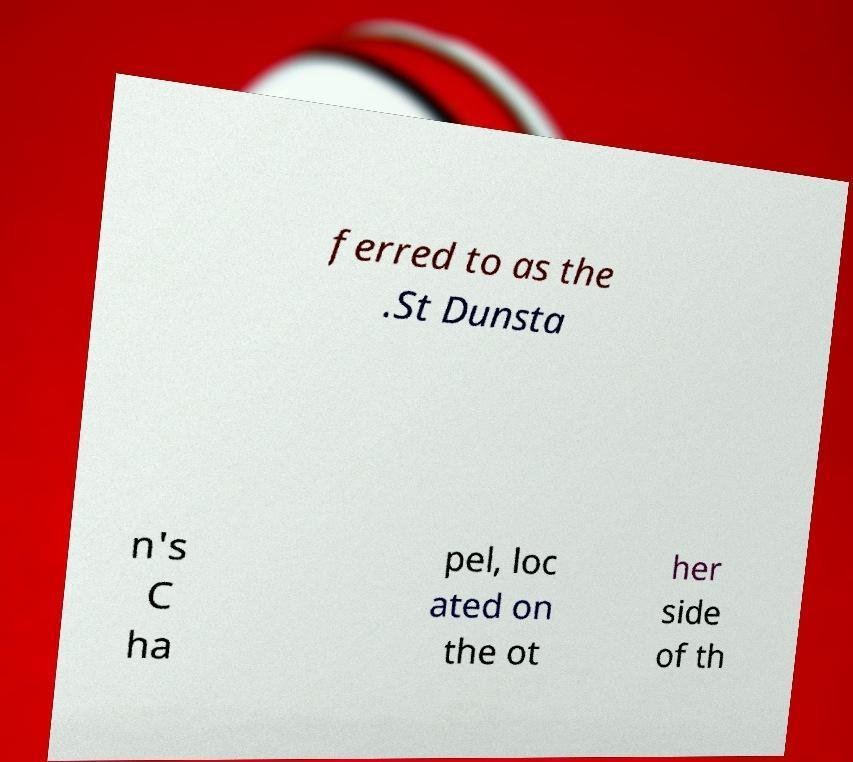I need the written content from this picture converted into text. Can you do that? ferred to as the .St Dunsta n's C ha pel, loc ated on the ot her side of th 